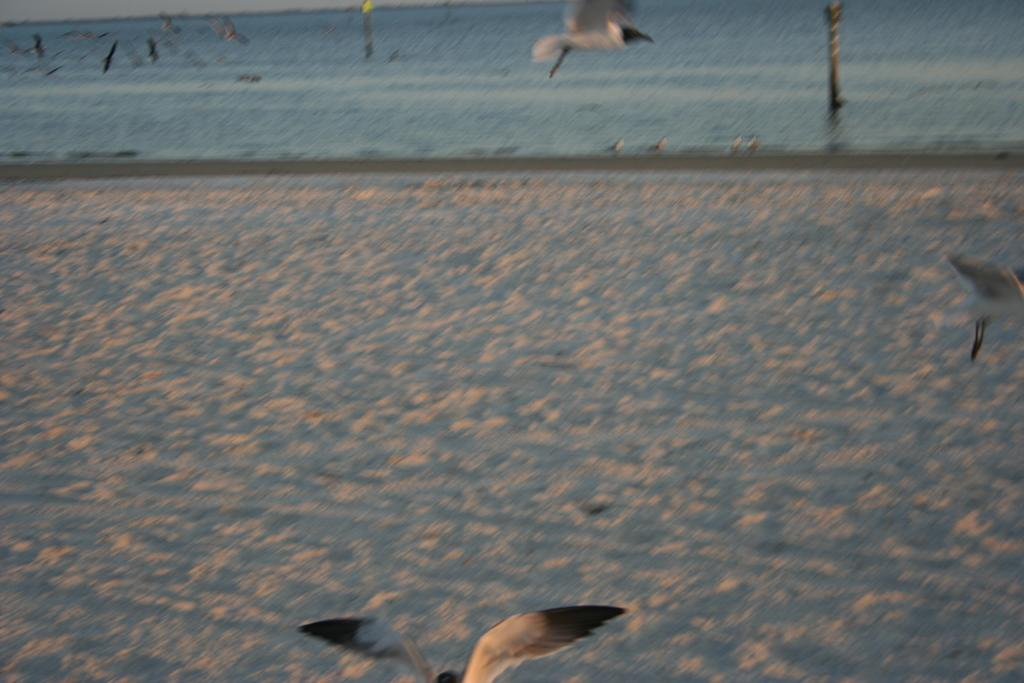What is happening in the image? There are birds flying in the image. What type of environment is depicted in the background? There is sand and water visible in the background of the image. What type of ornament is being held by the hand in the image? There is no hand or ornament present in the image; it features birds flying in a sandy and watery environment. 